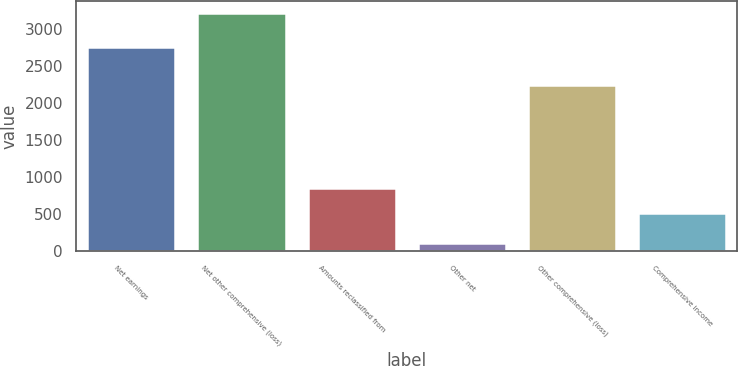Convert chart to OTSL. <chart><loc_0><loc_0><loc_500><loc_500><bar_chart><fcel>Net earnings<fcel>Net other comprehensive (loss)<fcel>Amounts reclassified from<fcel>Other net<fcel>Other comprehensive (loss)<fcel>Comprehensive income<nl><fcel>2745<fcel>3204<fcel>858<fcel>110<fcel>2236<fcel>509<nl></chart> 